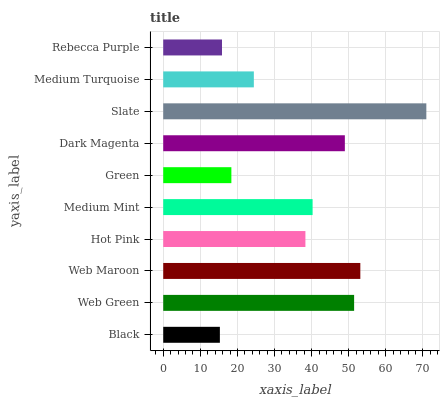Is Black the minimum?
Answer yes or no. Yes. Is Slate the maximum?
Answer yes or no. Yes. Is Web Green the minimum?
Answer yes or no. No. Is Web Green the maximum?
Answer yes or no. No. Is Web Green greater than Black?
Answer yes or no. Yes. Is Black less than Web Green?
Answer yes or no. Yes. Is Black greater than Web Green?
Answer yes or no. No. Is Web Green less than Black?
Answer yes or no. No. Is Medium Mint the high median?
Answer yes or no. Yes. Is Hot Pink the low median?
Answer yes or no. Yes. Is Dark Magenta the high median?
Answer yes or no. No. Is Rebecca Purple the low median?
Answer yes or no. No. 